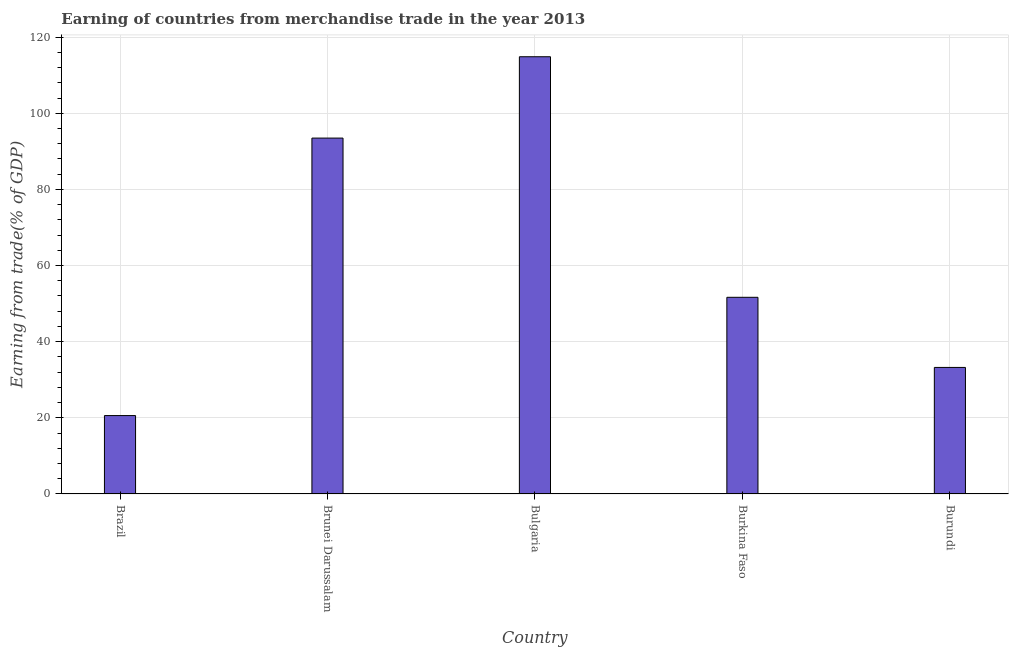Does the graph contain grids?
Your answer should be compact. Yes. What is the title of the graph?
Offer a very short reply. Earning of countries from merchandise trade in the year 2013. What is the label or title of the Y-axis?
Ensure brevity in your answer.  Earning from trade(% of GDP). What is the earning from merchandise trade in Burkina Faso?
Your response must be concise. 51.66. Across all countries, what is the maximum earning from merchandise trade?
Make the answer very short. 114.84. Across all countries, what is the minimum earning from merchandise trade?
Ensure brevity in your answer.  20.59. What is the sum of the earning from merchandise trade?
Provide a succinct answer. 313.8. What is the difference between the earning from merchandise trade in Bulgaria and Burkina Faso?
Provide a short and direct response. 63.19. What is the average earning from merchandise trade per country?
Your answer should be very brief. 62.76. What is the median earning from merchandise trade?
Give a very brief answer. 51.66. What is the ratio of the earning from merchandise trade in Brunei Darussalam to that in Burkina Faso?
Ensure brevity in your answer.  1.81. Is the earning from merchandise trade in Brunei Darussalam less than that in Burkina Faso?
Keep it short and to the point. No. What is the difference between the highest and the second highest earning from merchandise trade?
Provide a short and direct response. 21.37. Is the sum of the earning from merchandise trade in Bulgaria and Burkina Faso greater than the maximum earning from merchandise trade across all countries?
Make the answer very short. Yes. What is the difference between the highest and the lowest earning from merchandise trade?
Offer a terse response. 94.25. How many bars are there?
Offer a terse response. 5. Are all the bars in the graph horizontal?
Offer a very short reply. No. How many countries are there in the graph?
Keep it short and to the point. 5. Are the values on the major ticks of Y-axis written in scientific E-notation?
Give a very brief answer. No. What is the Earning from trade(% of GDP) of Brazil?
Keep it short and to the point. 20.59. What is the Earning from trade(% of GDP) of Brunei Darussalam?
Make the answer very short. 93.48. What is the Earning from trade(% of GDP) of Bulgaria?
Offer a terse response. 114.84. What is the Earning from trade(% of GDP) in Burkina Faso?
Give a very brief answer. 51.66. What is the Earning from trade(% of GDP) of Burundi?
Provide a short and direct response. 33.24. What is the difference between the Earning from trade(% of GDP) in Brazil and Brunei Darussalam?
Keep it short and to the point. -72.88. What is the difference between the Earning from trade(% of GDP) in Brazil and Bulgaria?
Give a very brief answer. -94.25. What is the difference between the Earning from trade(% of GDP) in Brazil and Burkina Faso?
Your answer should be compact. -31.06. What is the difference between the Earning from trade(% of GDP) in Brazil and Burundi?
Offer a terse response. -12.65. What is the difference between the Earning from trade(% of GDP) in Brunei Darussalam and Bulgaria?
Make the answer very short. -21.37. What is the difference between the Earning from trade(% of GDP) in Brunei Darussalam and Burkina Faso?
Give a very brief answer. 41.82. What is the difference between the Earning from trade(% of GDP) in Brunei Darussalam and Burundi?
Provide a succinct answer. 60.24. What is the difference between the Earning from trade(% of GDP) in Bulgaria and Burkina Faso?
Offer a terse response. 63.19. What is the difference between the Earning from trade(% of GDP) in Bulgaria and Burundi?
Your answer should be compact. 81.6. What is the difference between the Earning from trade(% of GDP) in Burkina Faso and Burundi?
Your answer should be compact. 18.42. What is the ratio of the Earning from trade(% of GDP) in Brazil to that in Brunei Darussalam?
Offer a very short reply. 0.22. What is the ratio of the Earning from trade(% of GDP) in Brazil to that in Bulgaria?
Give a very brief answer. 0.18. What is the ratio of the Earning from trade(% of GDP) in Brazil to that in Burkina Faso?
Ensure brevity in your answer.  0.4. What is the ratio of the Earning from trade(% of GDP) in Brazil to that in Burundi?
Provide a succinct answer. 0.62. What is the ratio of the Earning from trade(% of GDP) in Brunei Darussalam to that in Bulgaria?
Your answer should be very brief. 0.81. What is the ratio of the Earning from trade(% of GDP) in Brunei Darussalam to that in Burkina Faso?
Your response must be concise. 1.81. What is the ratio of the Earning from trade(% of GDP) in Brunei Darussalam to that in Burundi?
Make the answer very short. 2.81. What is the ratio of the Earning from trade(% of GDP) in Bulgaria to that in Burkina Faso?
Provide a succinct answer. 2.22. What is the ratio of the Earning from trade(% of GDP) in Bulgaria to that in Burundi?
Your answer should be compact. 3.46. What is the ratio of the Earning from trade(% of GDP) in Burkina Faso to that in Burundi?
Give a very brief answer. 1.55. 